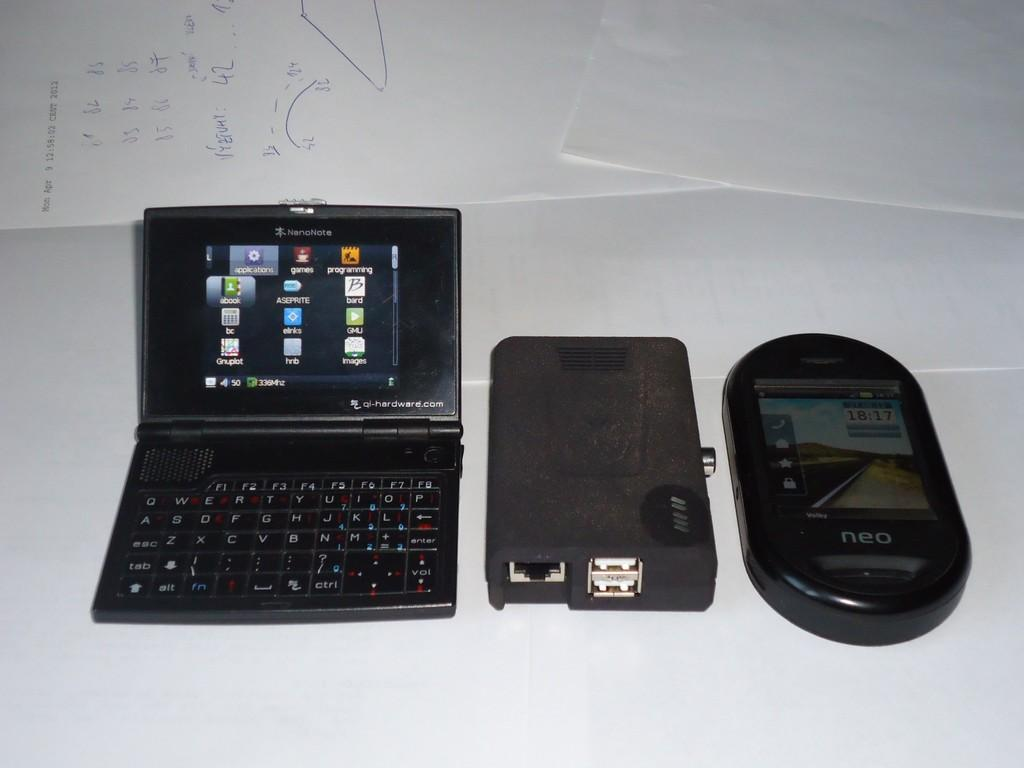<image>
Provide a brief description of the given image. A laptop with the lid raised and the screen has icons on it, one that reads games. 